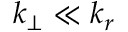<formula> <loc_0><loc_0><loc_500><loc_500>k _ { \perp } \ll k _ { r }</formula> 